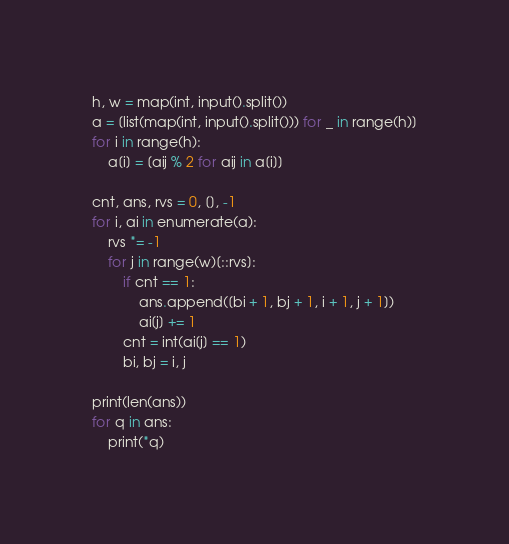<code> <loc_0><loc_0><loc_500><loc_500><_Python_>h, w = map(int, input().split())
a = [list(map(int, input().split())) for _ in range(h)]
for i in range(h):
    a[i] = [aij % 2 for aij in a[i]]

cnt, ans, rvs = 0, [], -1
for i, ai in enumerate(a):
    rvs *= -1
    for j in range(w)[::rvs]:
        if cnt == 1:
            ans.append([bi + 1, bj + 1, i + 1, j + 1])
            ai[j] += 1
        cnt = int(ai[j] == 1)
        bi, bj = i, j

print(len(ans))
for q in ans:
    print(*q)
</code> 